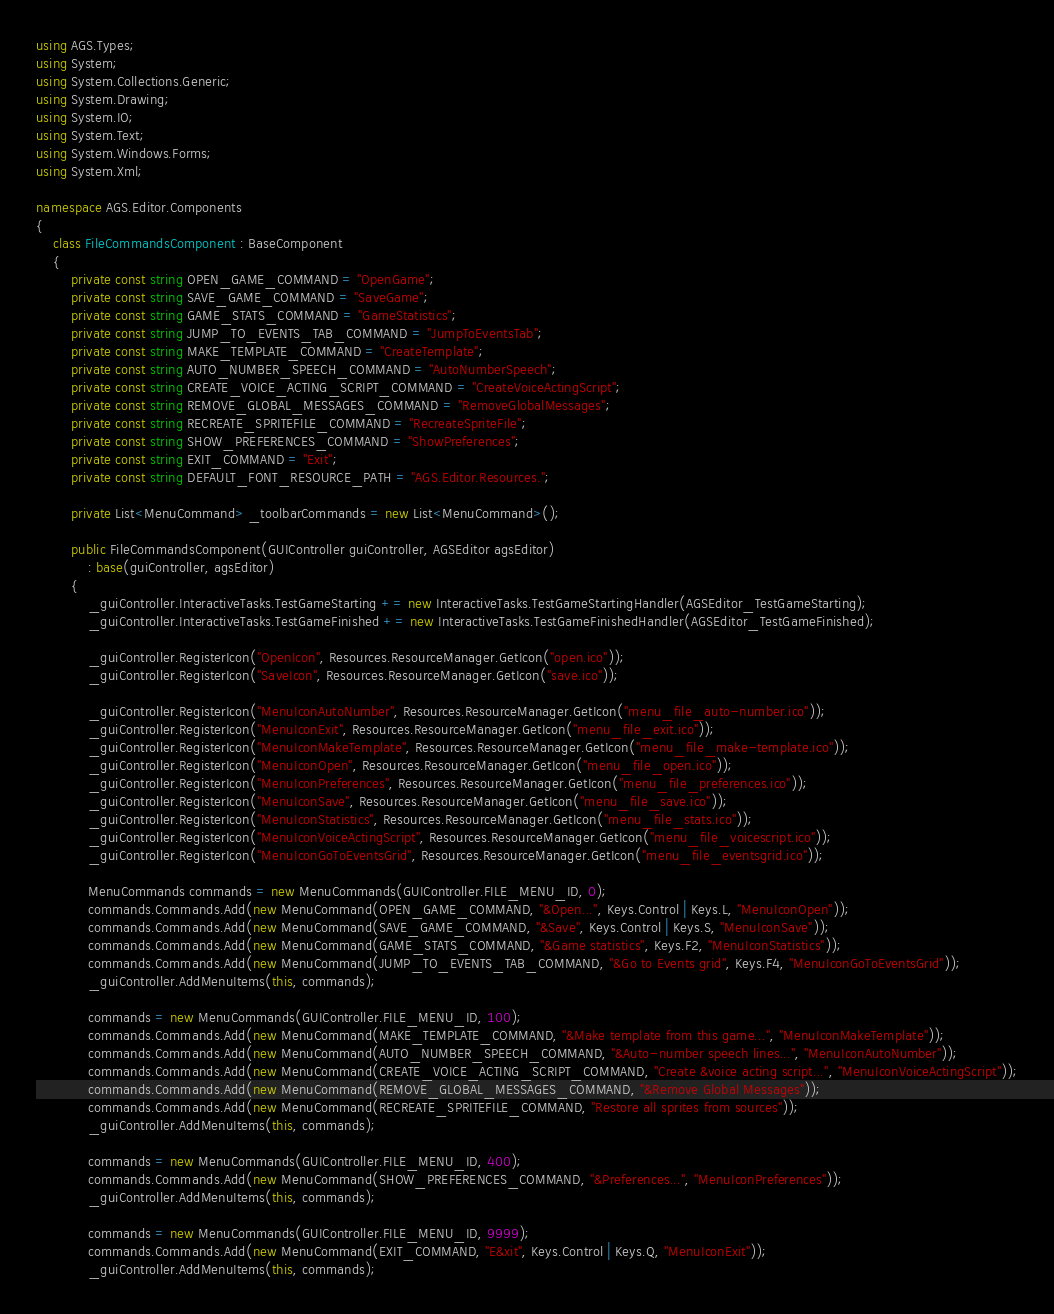<code> <loc_0><loc_0><loc_500><loc_500><_C#_>using AGS.Types;
using System;
using System.Collections.Generic;
using System.Drawing;
using System.IO;
using System.Text;
using System.Windows.Forms;
using System.Xml;

namespace AGS.Editor.Components
{
    class FileCommandsComponent : BaseComponent
    {
        private const string OPEN_GAME_COMMAND = "OpenGame";
        private const string SAVE_GAME_COMMAND = "SaveGame";
        private const string GAME_STATS_COMMAND = "GameStatistics";
        private const string JUMP_TO_EVENTS_TAB_COMMAND = "JumpToEventsTab";
        private const string MAKE_TEMPLATE_COMMAND = "CreateTemplate";
        private const string AUTO_NUMBER_SPEECH_COMMAND = "AutoNumberSpeech";
		private const string CREATE_VOICE_ACTING_SCRIPT_COMMAND = "CreateVoiceActingScript";
        private const string REMOVE_GLOBAL_MESSAGES_COMMAND = "RemoveGlobalMessages";
        private const string RECREATE_SPRITEFILE_COMMAND = "RecreateSpriteFile";
        private const string SHOW_PREFERENCES_COMMAND = "ShowPreferences";
        private const string EXIT_COMMAND = "Exit";
        private const string DEFAULT_FONT_RESOURCE_PATH = "AGS.Editor.Resources.";

        private List<MenuCommand> _toolbarCommands = new List<MenuCommand>();

        public FileCommandsComponent(GUIController guiController, AGSEditor agsEditor)
            : base(guiController, agsEditor)
        {
            _guiController.InteractiveTasks.TestGameStarting += new InteractiveTasks.TestGameStartingHandler(AGSEditor_TestGameStarting);
            _guiController.InteractiveTasks.TestGameFinished += new InteractiveTasks.TestGameFinishedHandler(AGSEditor_TestGameFinished);

            _guiController.RegisterIcon("OpenIcon", Resources.ResourceManager.GetIcon("open.ico"));
            _guiController.RegisterIcon("SaveIcon", Resources.ResourceManager.GetIcon("save.ico"));

            _guiController.RegisterIcon("MenuIconAutoNumber", Resources.ResourceManager.GetIcon("menu_file_auto-number.ico"));
            _guiController.RegisterIcon("MenuIconExit", Resources.ResourceManager.GetIcon("menu_file_exit.ico"));
            _guiController.RegisterIcon("MenuIconMakeTemplate", Resources.ResourceManager.GetIcon("menu_file_make-template.ico"));
            _guiController.RegisterIcon("MenuIconOpen", Resources.ResourceManager.GetIcon("menu_file_open.ico"));
            _guiController.RegisterIcon("MenuIconPreferences", Resources.ResourceManager.GetIcon("menu_file_preferences.ico"));
            _guiController.RegisterIcon("MenuIconSave", Resources.ResourceManager.GetIcon("menu_file_save.ico"));
            _guiController.RegisterIcon("MenuIconStatistics", Resources.ResourceManager.GetIcon("menu_file_stats.ico"));
            _guiController.RegisterIcon("MenuIconVoiceActingScript", Resources.ResourceManager.GetIcon("menu_file_voicescript.ico"));
            _guiController.RegisterIcon("MenuIconGoToEventsGrid", Resources.ResourceManager.GetIcon("menu_file_eventsgrid.ico"));

            MenuCommands commands = new MenuCommands(GUIController.FILE_MENU_ID, 0);
            commands.Commands.Add(new MenuCommand(OPEN_GAME_COMMAND, "&Open...", Keys.Control | Keys.L, "MenuIconOpen"));
            commands.Commands.Add(new MenuCommand(SAVE_GAME_COMMAND, "&Save", Keys.Control | Keys.S, "MenuIconSave"));
            commands.Commands.Add(new MenuCommand(GAME_STATS_COMMAND, "&Game statistics", Keys.F2, "MenuIconStatistics"));
            commands.Commands.Add(new MenuCommand(JUMP_TO_EVENTS_TAB_COMMAND, "&Go to Events grid", Keys.F4, "MenuIconGoToEventsGrid"));
            _guiController.AddMenuItems(this, commands);

			commands = new MenuCommands(GUIController.FILE_MENU_ID, 100);
			commands.Commands.Add(new MenuCommand(MAKE_TEMPLATE_COMMAND, "&Make template from this game...", "MenuIconMakeTemplate"));
            commands.Commands.Add(new MenuCommand(AUTO_NUMBER_SPEECH_COMMAND, "&Auto-number speech lines...", "MenuIconAutoNumber"));
			commands.Commands.Add(new MenuCommand(CREATE_VOICE_ACTING_SCRIPT_COMMAND, "Create &voice acting script...", "MenuIconVoiceActingScript"));
            commands.Commands.Add(new MenuCommand(REMOVE_GLOBAL_MESSAGES_COMMAND, "&Remove Global Messages"));
            commands.Commands.Add(new MenuCommand(RECREATE_SPRITEFILE_COMMAND, "Restore all sprites from sources"));
            _guiController.AddMenuItems(this, commands);

			commands = new MenuCommands(GUIController.FILE_MENU_ID, 400);
			commands.Commands.Add(new MenuCommand(SHOW_PREFERENCES_COMMAND, "&Preferences...", "MenuIconPreferences"));
			_guiController.AddMenuItems(this, commands);

			commands = new MenuCommands(GUIController.FILE_MENU_ID, 9999);
			commands.Commands.Add(new MenuCommand(EXIT_COMMAND, "E&xit", Keys.Control | Keys.Q, "MenuIconExit"));
			_guiController.AddMenuItems(this, commands);
</code> 